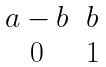<formula> <loc_0><loc_0><loc_500><loc_500>\begin{matrix} a - b & b \\ 0 & 1 \end{matrix}</formula> 